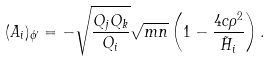<formula> <loc_0><loc_0><loc_500><loc_500>( A _ { i } ) _ { \phi ^ { \prime } } = - \sqrt { \frac { Q _ { j } Q _ { k } } { Q _ { i } } } \sqrt { m n } \left ( 1 - \frac { 4 c \rho ^ { 2 } } { \tilde { H } _ { i } } \right ) .</formula> 